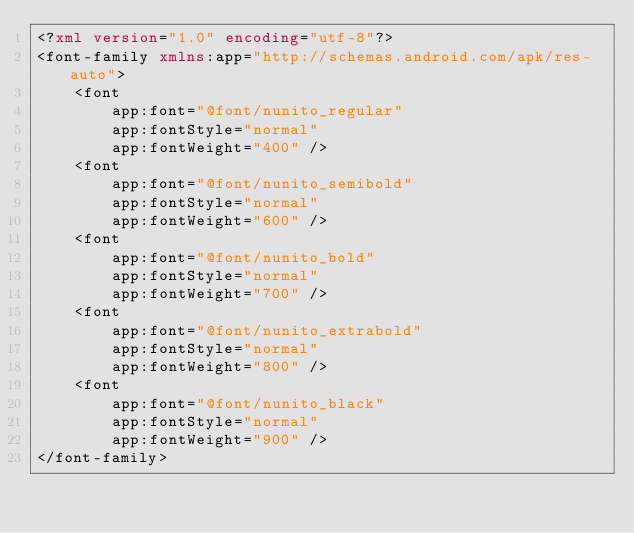<code> <loc_0><loc_0><loc_500><loc_500><_XML_><?xml version="1.0" encoding="utf-8"?>
<font-family xmlns:app="http://schemas.android.com/apk/res-auto">
    <font
        app:font="@font/nunito_regular"
        app:fontStyle="normal"
        app:fontWeight="400" />
    <font
        app:font="@font/nunito_semibold"
        app:fontStyle="normal"
        app:fontWeight="600" />
    <font
        app:font="@font/nunito_bold"
        app:fontStyle="normal"
        app:fontWeight="700" />
    <font
        app:font="@font/nunito_extrabold"
        app:fontStyle="normal"
        app:fontWeight="800" />
    <font
        app:font="@font/nunito_black"
        app:fontStyle="normal"
        app:fontWeight="900" />
</font-family>
</code> 